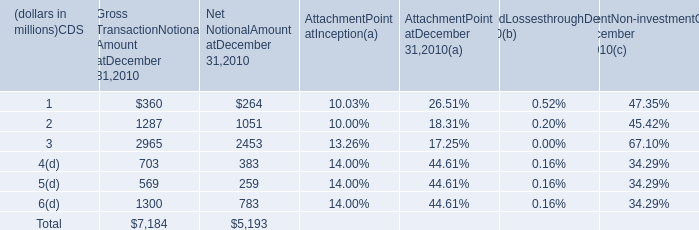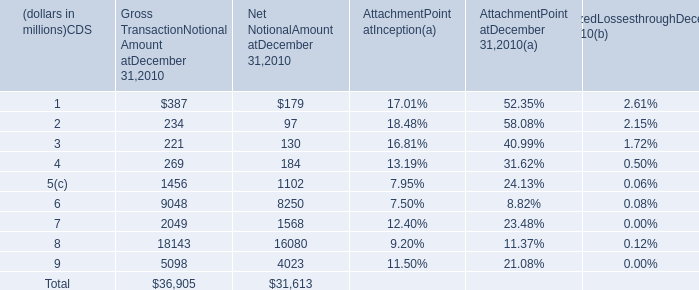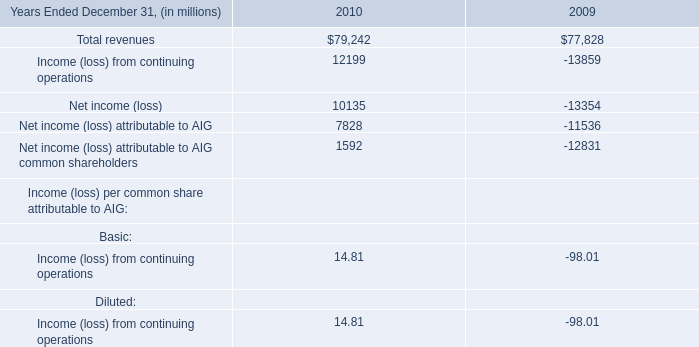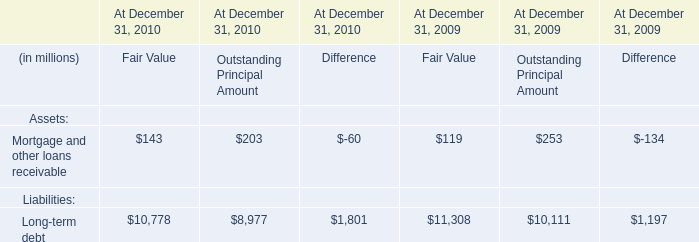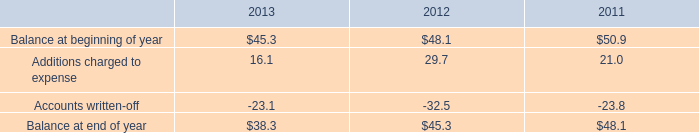In what year is Attachment Point at Inception greater than 10.00%? 
Answer: 2010. 